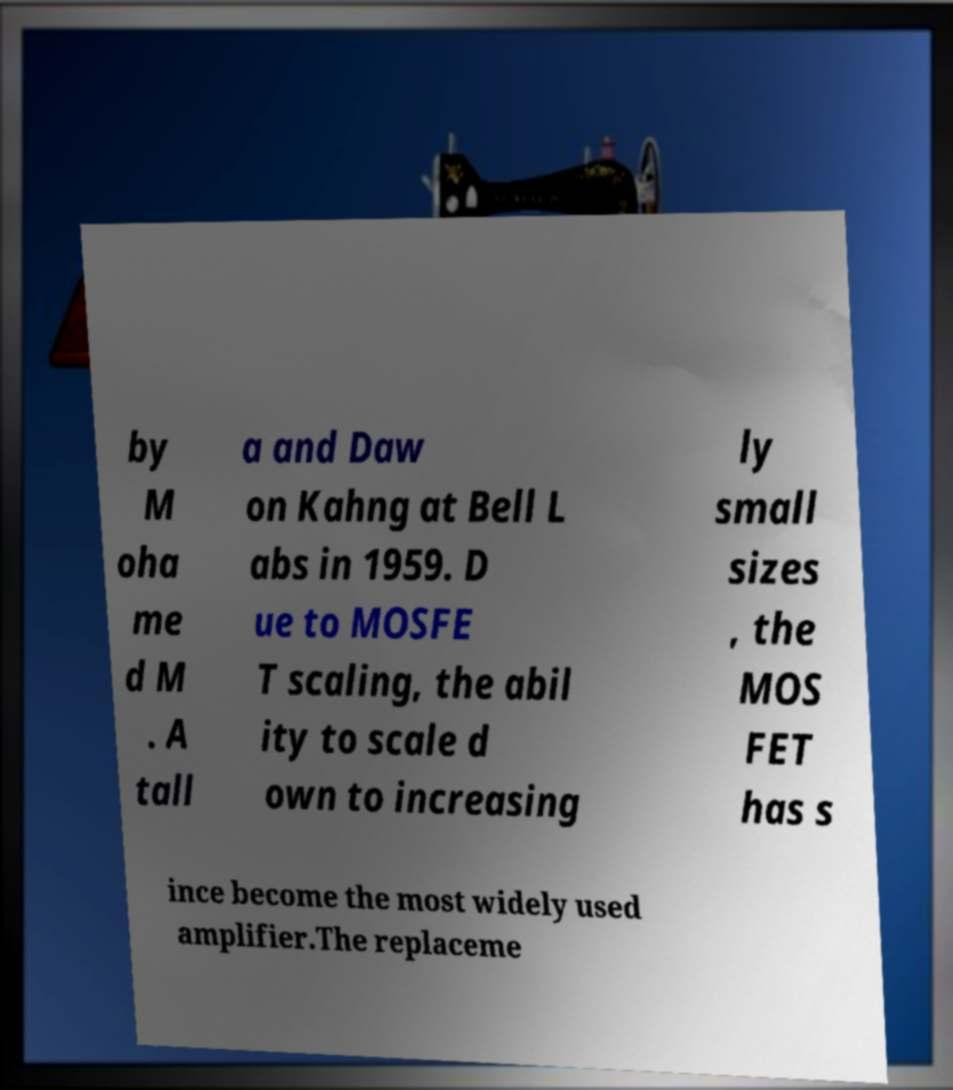What messages or text are displayed in this image? I need them in a readable, typed format. by M oha me d M . A tall a and Daw on Kahng at Bell L abs in 1959. D ue to MOSFE T scaling, the abil ity to scale d own to increasing ly small sizes , the MOS FET has s ince become the most widely used amplifier.The replaceme 